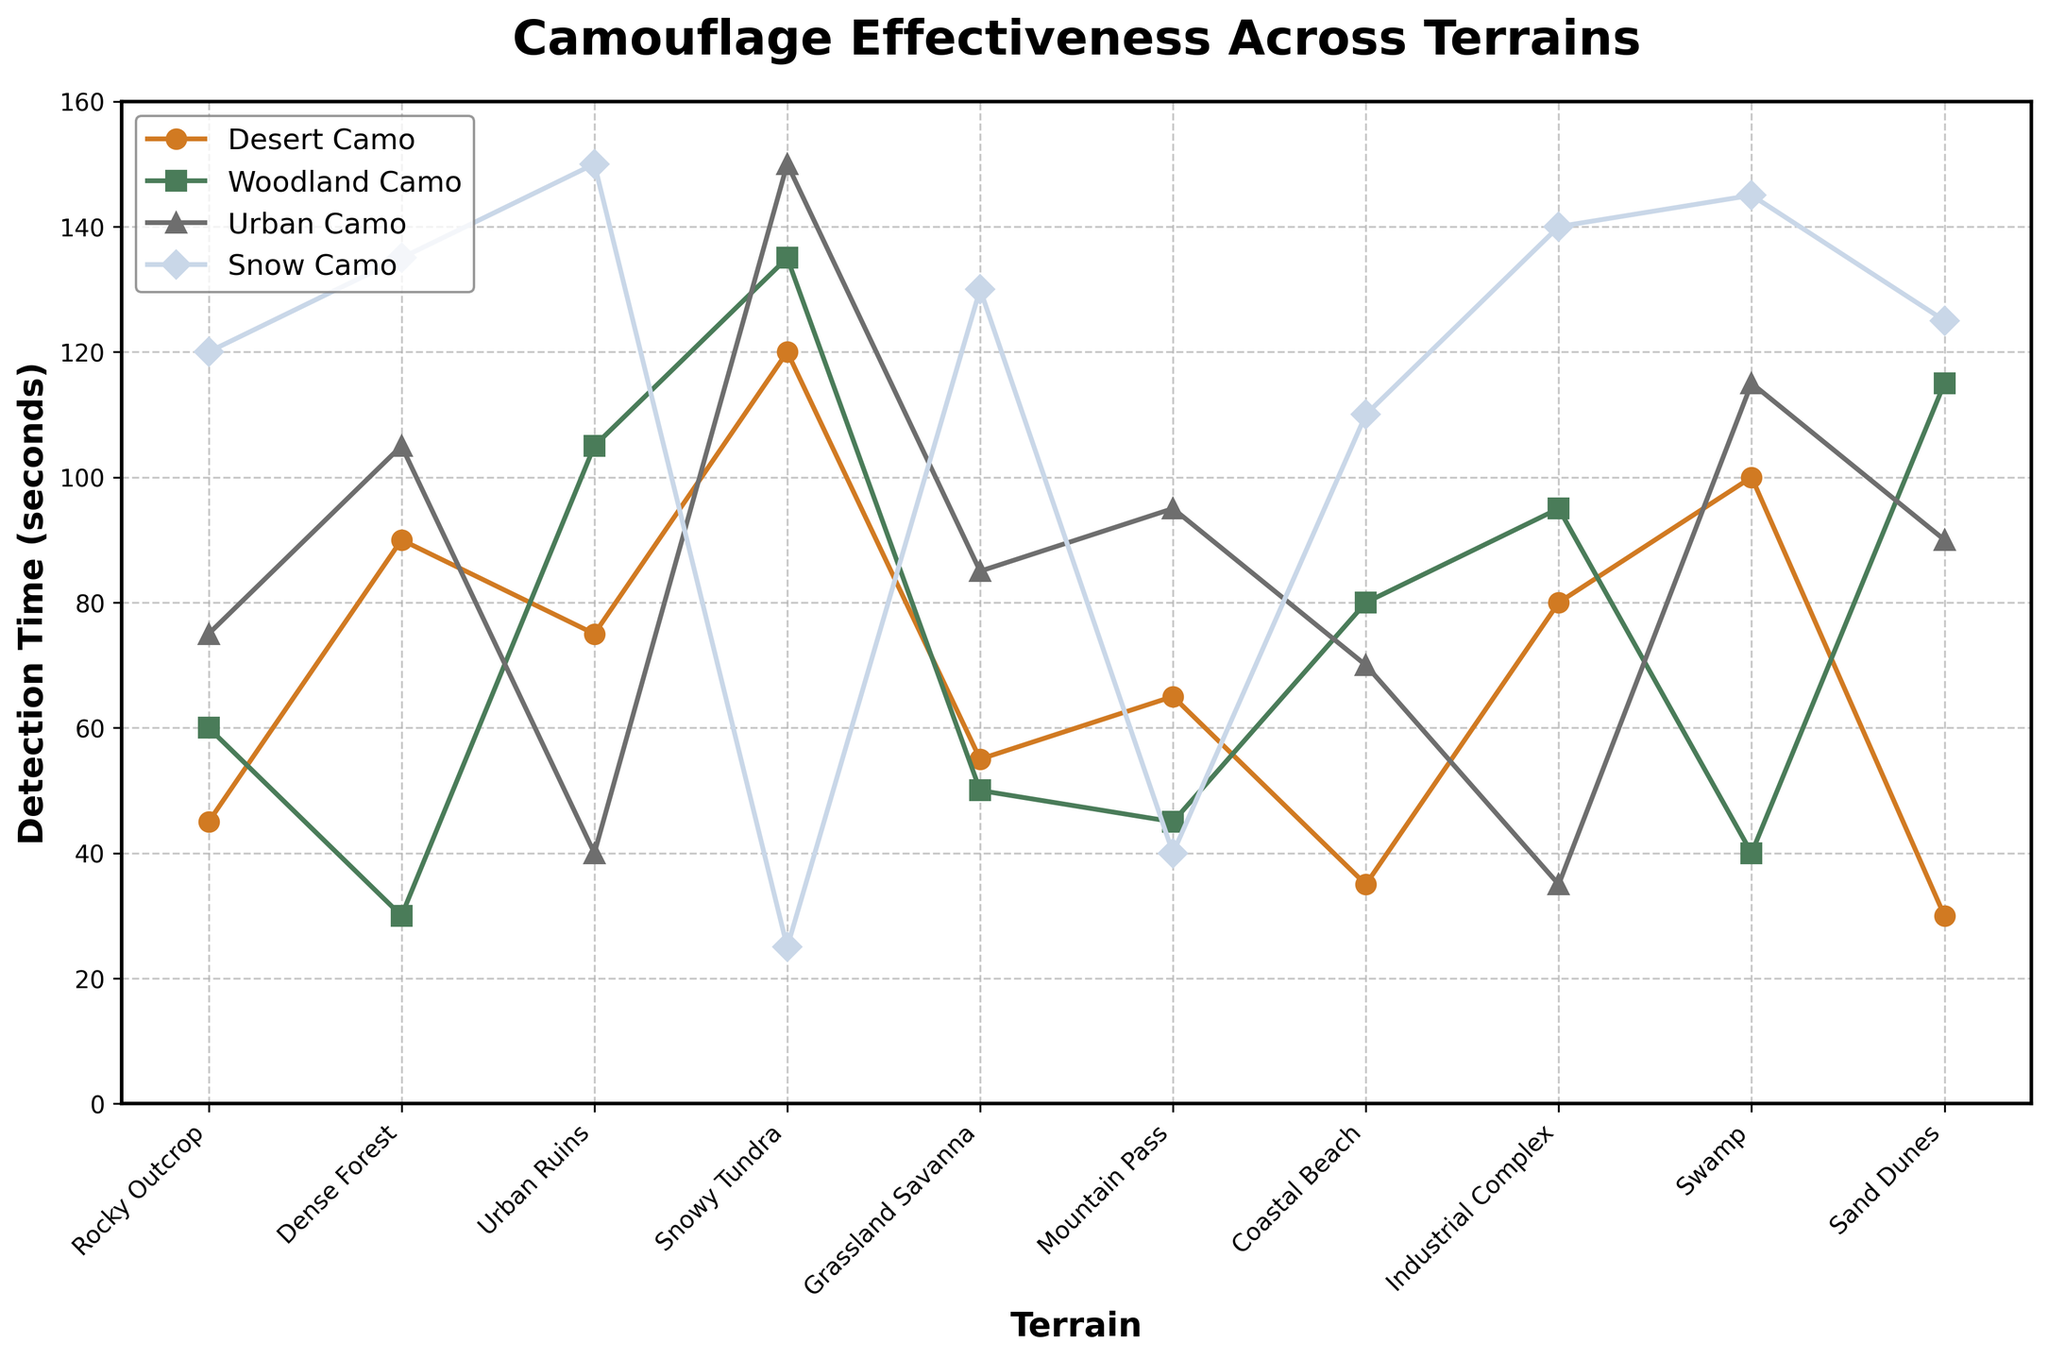What's the terrain where Snow Camo has the highest detection time? Snow Camo's detection times vary according to terrain. By looking at the highest value, which is 150 seconds, we see it occurs at Urban Ruins.
Answer: Urban Ruins Which camouflage type is most effective in Dense Forest? The most effective camouflage has the highest detection time. For Dense Forest, the highest detection time is Desert Camo at 90 seconds.
Answer: Desert Camo What's the average detection time for Urban Camo across all terrains? To find the average, sum the detection times for Urban Camo (75 + 105 + 40 + 150 + 85 + 95 + 70 + 35 + 115 + 90) = 860, then divide by the number of terrains (10): 860/10 = 86 seconds.
Answer: 86 seconds Which camo type has the smallest detection time in Snowy Tundra? Looking at Snowy Tundra's row, the smallest detection time is for Snow Camo with 25 seconds.
Answer: Snow Camo Compare the effectiveness of Woodland Camo and Desert Camo in Mountain Pass. Which is better? Better effectiveness means higher detection time. In Mountain Pass, Woodland Camo's detection time is 45 seconds, and Desert Camo's is 65 seconds. Hence, Desert Camo is better.
Answer: Desert Camo What is the terrain where Desert Camo is least effective? The least effective implies the lowest detection time for Desert Camo. The lowest value is 30 seconds, which occurs in Sand Dunes.
Answer: Sand Dunes Which camouflage has the highest detection time overall and in which terrain does it occur? The highest detection time overall is 150 seconds, which is for both Urban Camo in Snowy Tundra and Snow Camo in Urban Ruins.
Answer: Urban Camo (Snowy Tundra), Snow Camo (Urban Ruins) By how much is Desert Camo more effective than Snow Camo in Rocky Outcrop? Subtract Snow Camo's detection time from Desert Camo's detection time in Rocky Outcrop (45 - 120) = -75 seconds, indicating Desert Camo is more effective by 75 seconds.
Answer: 75 seconds What's the total detection time for Woodland Camo across Coastal Beach, Industrial Complex, and Swamp? Add the detection times for Woodland Camo in these terrains (80 + 95 + 40) = 215 seconds.
Answer: 215 seconds In which two terrains does Swamp share the same detection time for any camouflage? Identify the camouflage too. Swamp and Dense Forest both have a detection time of 135 seconds for Snow Camo.
Answer: Swamp, Dense Forest, Snow Camo 